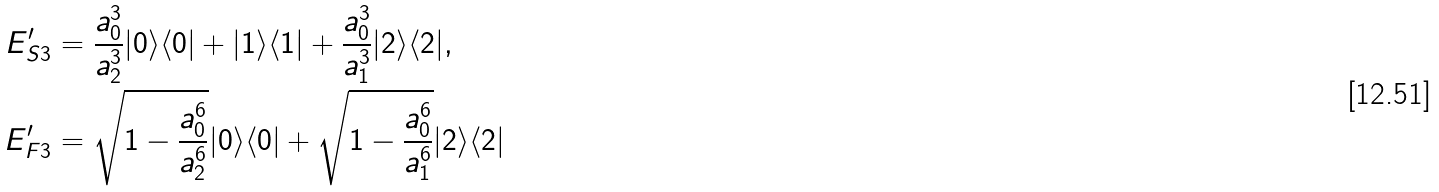<formula> <loc_0><loc_0><loc_500><loc_500>E ^ { \prime } _ { S 3 } & = \frac { a _ { 0 } ^ { 3 } } { a _ { 2 } ^ { 3 } } | 0 \rangle \langle 0 | + | 1 \rangle \langle 1 | + \frac { a _ { 0 } ^ { 3 } } { a _ { 1 } ^ { 3 } } | 2 \rangle \langle 2 | , \\ E ^ { \prime } _ { F 3 } & = \sqrt { 1 - \frac { a _ { 0 } ^ { 6 } } { a _ { 2 } ^ { 6 } } } | 0 \rangle \langle 0 | + \sqrt { 1 - \frac { a _ { 0 } ^ { 6 } } { a _ { 1 } ^ { 6 } } } | 2 \rangle \langle 2 |</formula> 